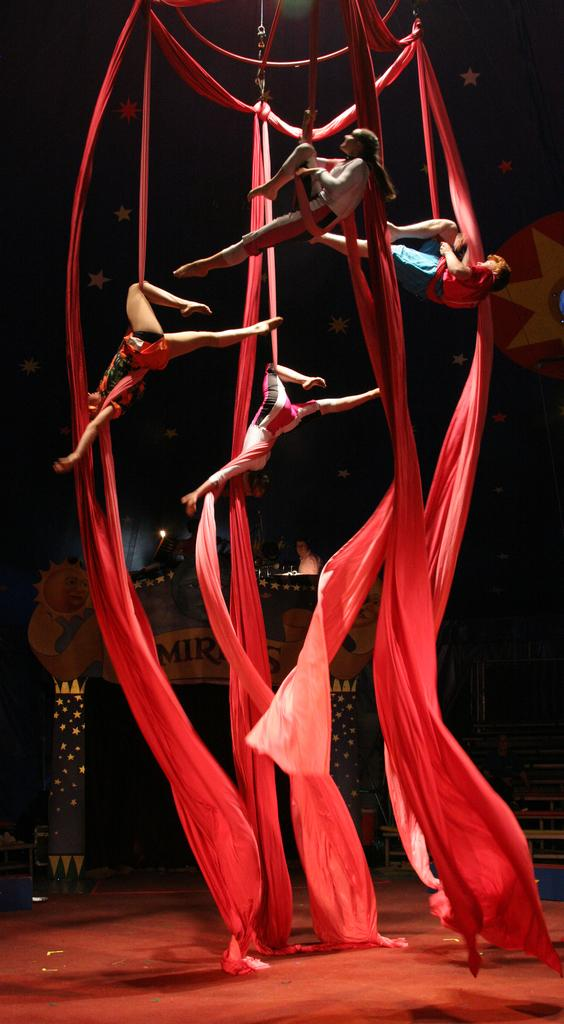What type of equipment is present in the image? There is a static trapeze in the image. What additional elements can be seen in the image? There are stars and a decorated arch in the image. What type of soda is being served under the decorated arch in the image? There is no soda present in the image; it features a static trapeze, stars, and a decorated arch. What color is the yarn used to decorate the trapeze in the image? There is no yarn present in the image; it features a static trapeze, stars, and a decorated arch. 